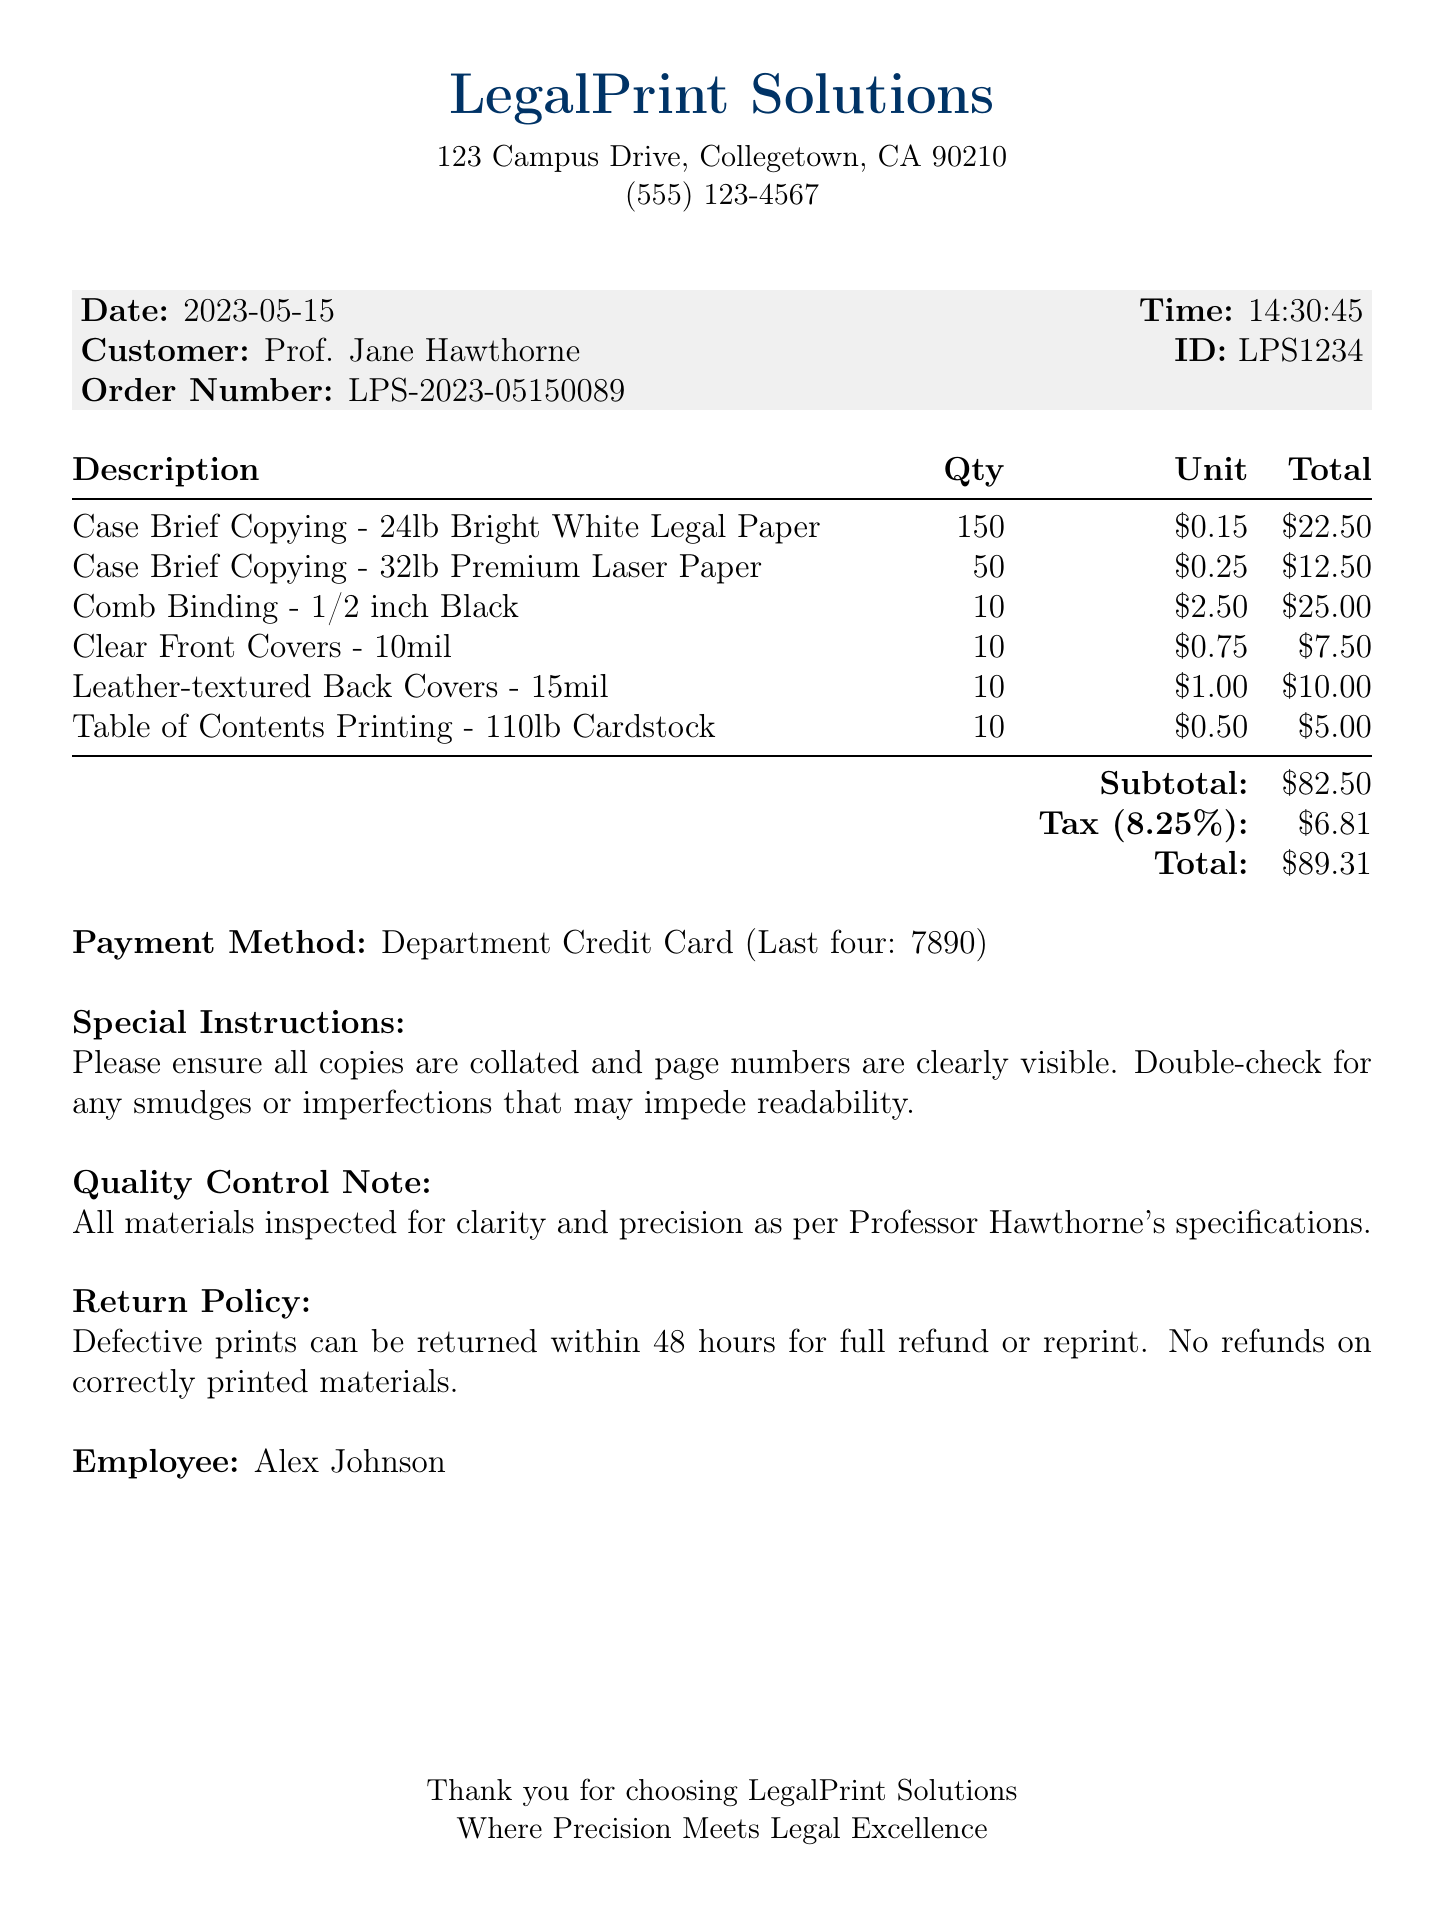What is the date of the transaction? The date is explicitly stated in the document.
Answer: 2023-05-15 Who is the customer? The customer's name is mentioned clearly in the document.
Answer: Prof. Jane Hawthorne What is the total amount charged? The total amount is provided at the bottom of the receipt in a clear format.
Answer: $89.31 How many Case Brief Copies were made on 24lb paper? The quantity for this specific item is listed in the itemized section.
Answer: 150 What is the payment method used? The method of payment is specified in the document.
Answer: Department Credit Card How much was spent on Comb Binding? The total for this line item is shown in the itemized list.
Answer: $25.00 What does the quality control note indicate? This section outlines the standard for inspecting materials according to specifications.
Answer: All materials inspected for clarity and precision as per Professor Hawthorne's specifications What is the return policy for defective prints? The return policy details are included in the document.
Answer: Defective prints can be returned within 48 hours for full refund or reprint What is the subtotal before tax? The subtotal before tax is given directly in the document.
Answer: $82.50 What is the card's last four digits used for payment? The last four digits of the card used are provided in the payment method section.
Answer: 7890 